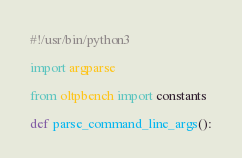<code> <loc_0><loc_0><loc_500><loc_500><_Python_>#!/usr/bin/python3

import argparse

from oltpbench import constants

def parse_command_line_args():</code> 